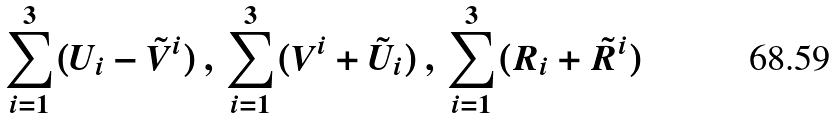Convert formula to latex. <formula><loc_0><loc_0><loc_500><loc_500>\sum _ { i = 1 } ^ { 3 } ( U _ { i } - \tilde { V } ^ { i } ) \, , \, \sum _ { i = 1 } ^ { 3 } ( V ^ { i } + \tilde { U } _ { i } ) \, , \, \sum _ { i = 1 } ^ { 3 } ( R _ { i } + \tilde { R } ^ { i } )</formula> 